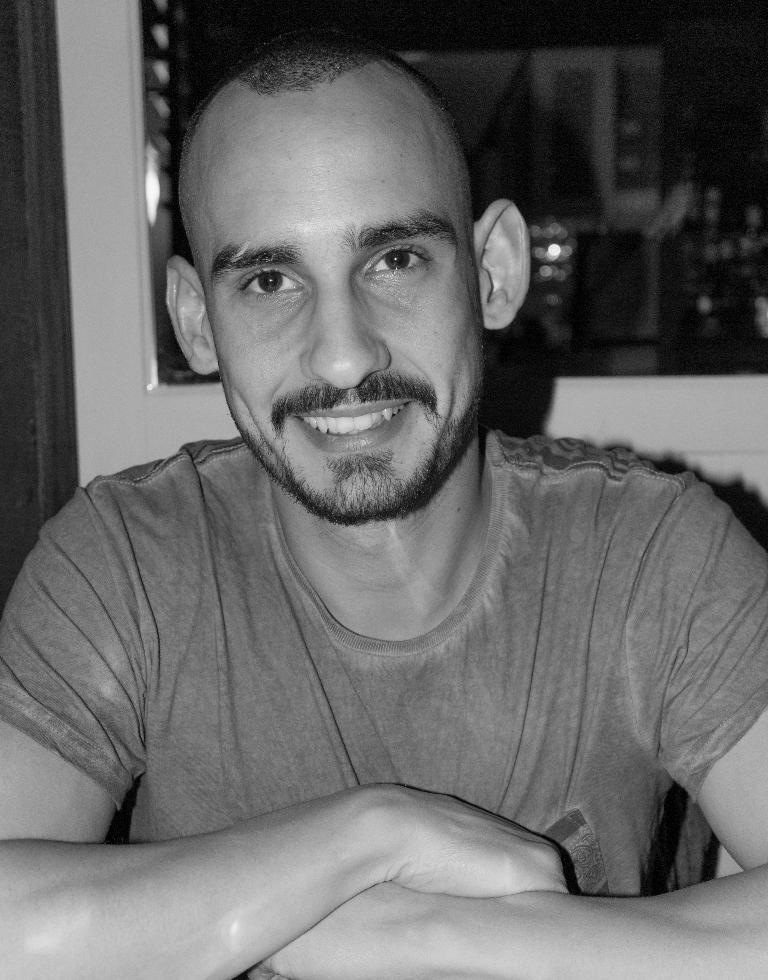How would you summarize this image in a sentence or two? In this picture I can see a person with a smile. 